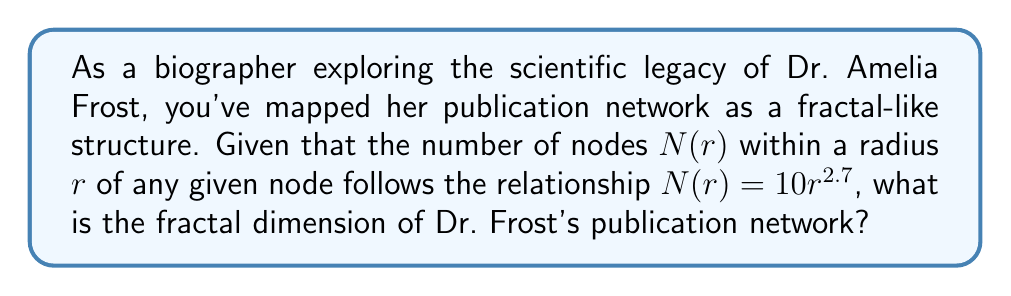Teach me how to tackle this problem. To determine the fractal dimension of Dr. Frost's publication network, we'll follow these steps:

1. Recall the general form of the fractal scaling relationship:
   $$N(r) = kr^D$$
   where $k$ is a constant, $r$ is the radius, and $D$ is the fractal dimension.

2. Compare this to the given relationship:
   $$N(r) = 10r^{2.7}$$

3. We can see that:
   $k = 10$
   $D = 2.7$

4. The fractal dimension is directly given by the exponent in this relationship.

Therefore, the fractal dimension of Dr. Frost's publication network is 2.7.

This non-integer dimension suggests that her publication network has a complexity between a 2-dimensional plane and a 3-dimensional space, reflecting the intricate interconnections of her research collaborations and scientific influence.
Answer: 2.7 